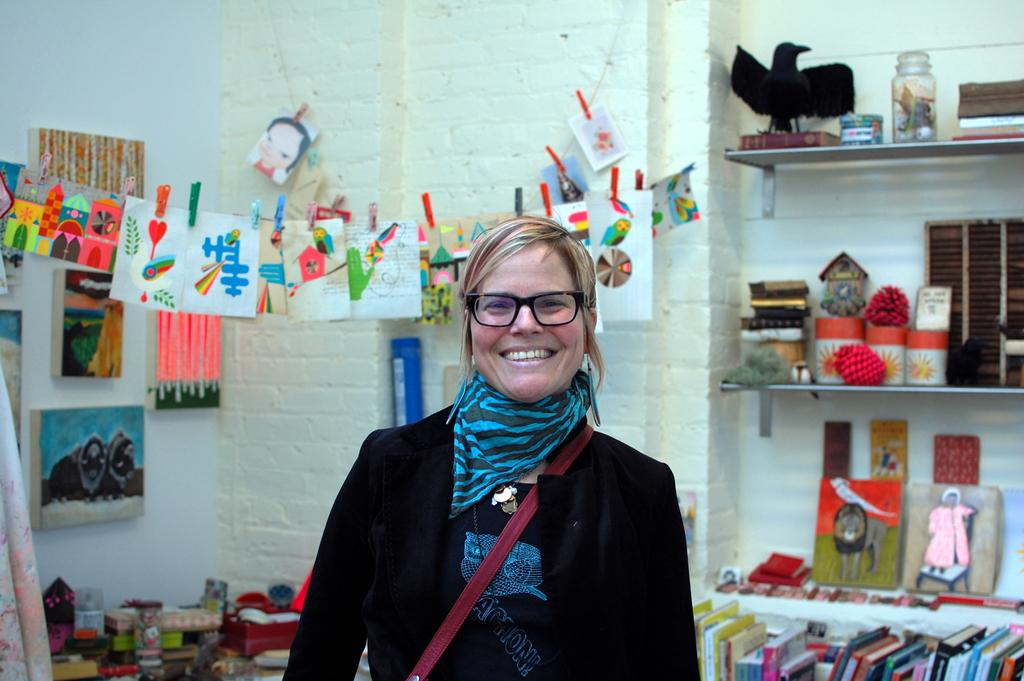Who is present in the image? There is a woman in the image. What can be seen on the right side of the image? There are cracks on the right side of the image. What items are visible in the image? There are books and papers in the image. What is visible in the background of the image? There is a wall in the background of the image. What type of cake is being cut with a plastic hammer in the image? There is no cake or plastic hammer present in the image. 